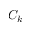Convert formula to latex. <formula><loc_0><loc_0><loc_500><loc_500>C _ { k }</formula> 